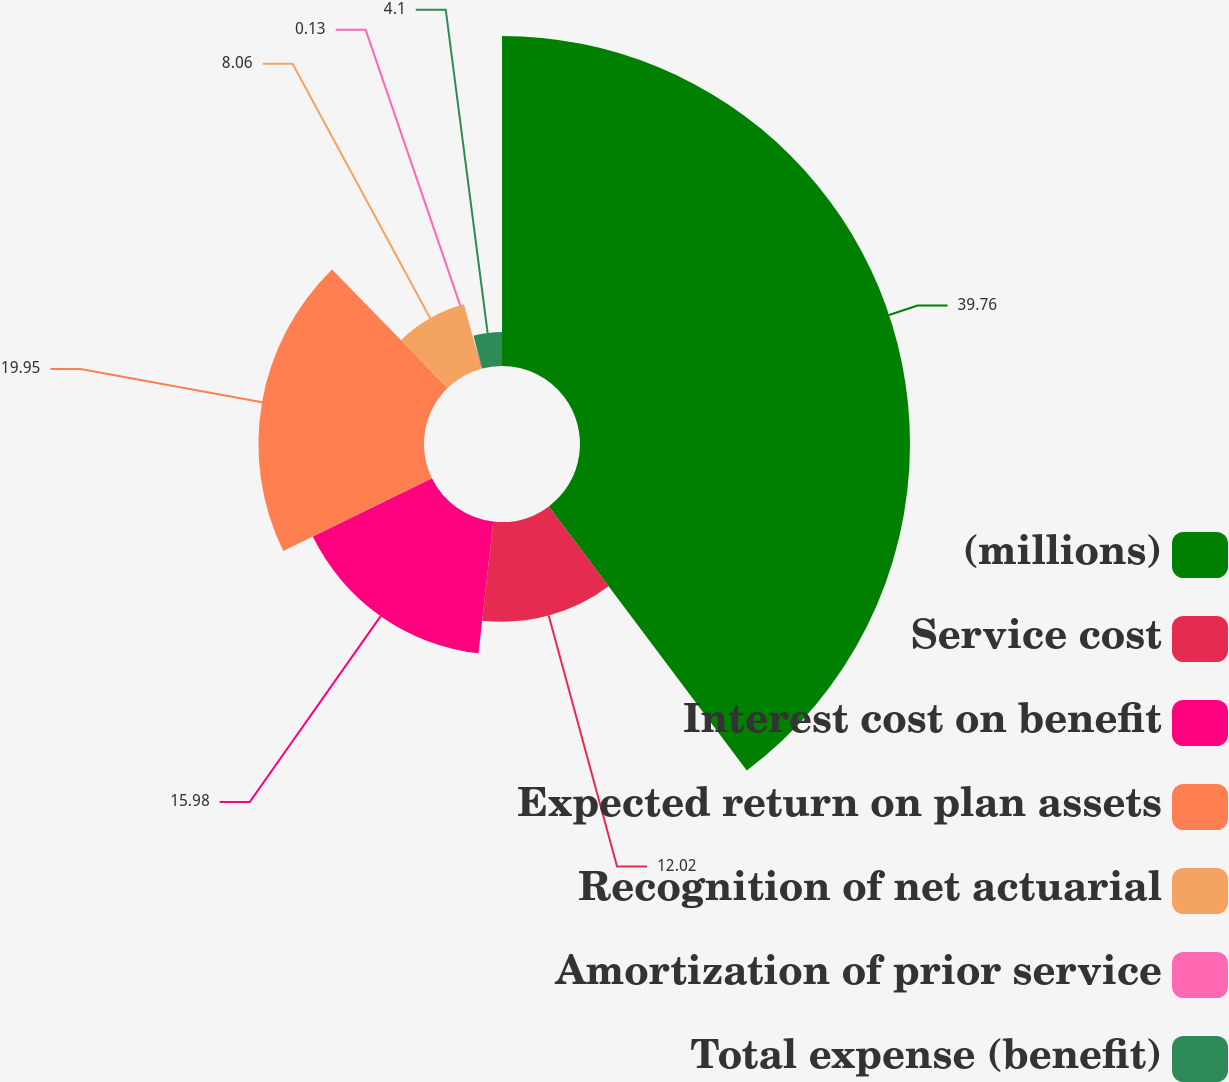<chart> <loc_0><loc_0><loc_500><loc_500><pie_chart><fcel>(millions)<fcel>Service cost<fcel>Interest cost on benefit<fcel>Expected return on plan assets<fcel>Recognition of net actuarial<fcel>Amortization of prior service<fcel>Total expense (benefit)<nl><fcel>39.76%<fcel>12.02%<fcel>15.98%<fcel>19.95%<fcel>8.06%<fcel>0.13%<fcel>4.1%<nl></chart> 